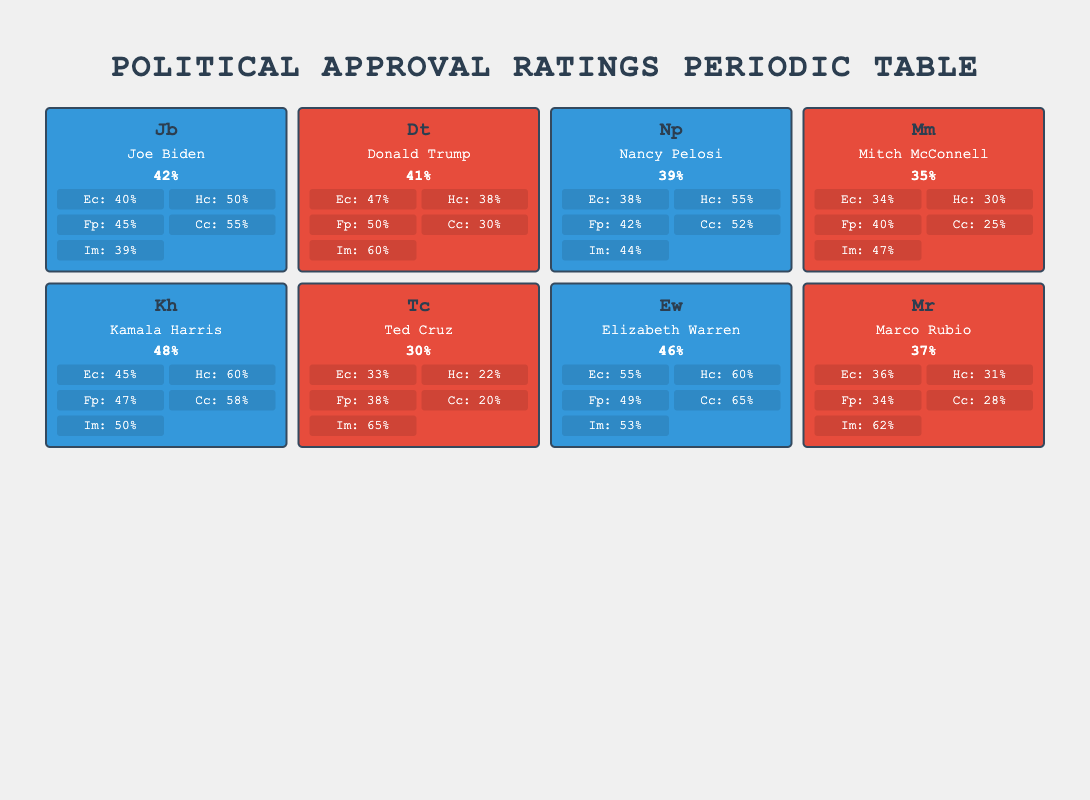What is the highest approval rating among the political leaders? The highest approval rating in the table is 48%, which belongs to Kamala Harris. This can be found by scanning the "ApprovalRating" column for the highest value.
Answer: 48% Which political leader has the lowest approval rating? Ted Cruz has the lowest approval rating at 30%. This is determined by looking for the minimum value in the "ApprovalRating" column.
Answer: 30% What is the average approval rating for the Democratic leaders? The average is calculated by summing the approval ratings of Joe Biden (42), Nancy Pelosi (39), Kamala Harris (48), and Elizabeth Warren (46) which sums to 175. There are 4 Democratic leaders, so dividing 175 by 4 gives an average of 43.75.
Answer: 43.75 Does Donald Trump have a higher approval rating on the economy compared to Joe Biden? Yes, Donald Trump's approval rating on the economy is 47%, while Joe Biden's is 40%. This is confirmed by comparing their respective "Economy" values in the "KeyIssues" section for each leader.
Answer: Yes How many key issues does Kamala Harris have an approval rating above 50%? Kamala Harris has approval ratings above 50% on Healthcare (60%), Climate Change (58%), and Economy (45%). Thus, she has 2 issues above 50%. This is found by counting the relevant values in her "KeyIssues" section.
Answer: 2 Which Republican leader has the highest approval rating for Immigration? Ted Cruz has the highest approval rating for Immigration at 65%. This is found by scanning the "Immigration" values under the Republican leaders and identifying the maximum.
Answer: 65% What is the difference between the highest and lowest approval ratings for the key issue of Climate Change? The highest approval rating for Climate Change is 65% (Elizabeth Warren) and the lowest is 20% (Ted Cruz). The difference is calculated as 65 - 20 = 45.
Answer: 45 Identify the political leader with the highest approval rating in Foreign Policy. Donald Trump has the highest approval rating in Foreign Policy at 50%. To answer, one needs to review the "ForeignPolicy" ratings and find the highest.
Answer: 50 How many leaders have a total average approval rating below 40%? Two leaders, Mitch McConnell (35%) and Ted Cruz (30%), have approval ratings below 40%. The answer is obtained by counting the number of leaders whose "ApprovalRating" is less than 40%.
Answer: 2 